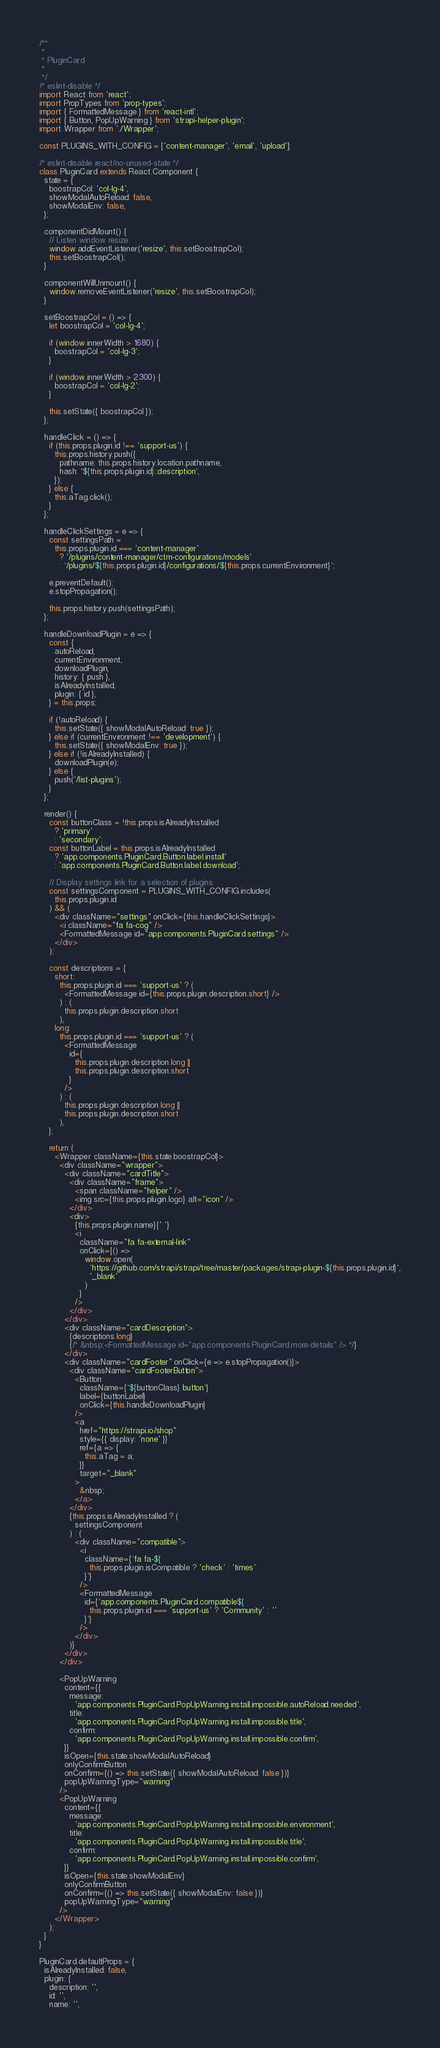<code> <loc_0><loc_0><loc_500><loc_500><_JavaScript_>/**
 *
 * PluginCard
 *
 */
/* eslint-disable */
import React from 'react';
import PropTypes from 'prop-types';
import { FormattedMessage } from 'react-intl';
import { Button, PopUpWarning } from 'strapi-helper-plugin';
import Wrapper from './Wrapper';

const PLUGINS_WITH_CONFIG = ['content-manager', 'email', 'upload'];

/* eslint-disable react/no-unused-state */
class PluginCard extends React.Component {
  state = {
    boostrapCol: 'col-lg-4',
    showModalAutoReload: false,
    showModalEnv: false,
  };

  componentDidMount() {
    // Listen window resize.
    window.addEventListener('resize', this.setBoostrapCol);
    this.setBoostrapCol();
  }

  componentWillUnmount() {
    window.removeEventListener('resize', this.setBoostrapCol);
  }

  setBoostrapCol = () => {
    let boostrapCol = 'col-lg-4';

    if (window.innerWidth > 1680) {
      boostrapCol = 'col-lg-3';
    }

    if (window.innerWidth > 2300) {
      boostrapCol = 'col-lg-2';
    }

    this.setState({ boostrapCol });
  };

  handleClick = () => {
    if (this.props.plugin.id !== 'support-us') {
      this.props.history.push({
        pathname: this.props.history.location.pathname,
        hash: `${this.props.plugin.id}::description`,
      });
    } else {
      this.aTag.click();
    }
  };

  handleClickSettings = e => {
    const settingsPath =
      this.props.plugin.id === 'content-manager'
        ? '/plugins/content-manager/ctm-configurations/models'
        : `/plugins/${this.props.plugin.id}/configurations/${this.props.currentEnvironment}`;

    e.preventDefault();
    e.stopPropagation();

    this.props.history.push(settingsPath);
  };

  handleDownloadPlugin = e => {
    const {
      autoReload,
      currentEnvironment,
      downloadPlugin,
      history: { push },
      isAlreadyInstalled,
      plugin: { id },
    } = this.props;

    if (!autoReload) {
      this.setState({ showModalAutoReload: true });
    } else if (currentEnvironment !== 'development') {
      this.setState({ showModalEnv: true });
    } else if (!isAlreadyInstalled) {
      downloadPlugin(e);
    } else {
      push('/list-plugins');
    }
  };

  render() {
    const buttonClass = !this.props.isAlreadyInstalled
      ? 'primary'
      : 'secondary';
    const buttonLabel = this.props.isAlreadyInstalled
      ? 'app.components.PluginCard.Button.label.install'
      : 'app.components.PluginCard.Button.label.download';

    // Display settings link for a selection of plugins.
    const settingsComponent = PLUGINS_WITH_CONFIG.includes(
      this.props.plugin.id
    ) && (
      <div className="settings" onClick={this.handleClickSettings}>
        <i className="fa fa-cog" />
        <FormattedMessage id="app.components.PluginCard.settings" />
      </div>
    );

    const descriptions = {
      short:
        this.props.plugin.id === 'support-us' ? (
          <FormattedMessage id={this.props.plugin.description.short} />
        ) : (
          this.props.plugin.description.short
        ),
      long:
        this.props.plugin.id === 'support-us' ? (
          <FormattedMessage
            id={
              this.props.plugin.description.long ||
              this.props.plugin.description.short
            }
          />
        ) : (
          this.props.plugin.description.long ||
          this.props.plugin.description.short
        ),
    };

    return (
      <Wrapper className={this.state.boostrapCol}>
        <div className="wrapper">
          <div className="cardTitle">
            <div className="frame">
              <span className="helper" />
              <img src={this.props.plugin.logo} alt="icon" />
            </div>
            <div>
              {this.props.plugin.name}{' '}
              <i
                className="fa fa-external-link"
                onClick={() =>
                  window.open(
                    `https://github.com/strapi/strapi/tree/master/packages/strapi-plugin-${this.props.plugin.id}`,
                    '_blank'
                  )
                }
              />
            </div>
          </div>
          <div className="cardDescription">
            {descriptions.long}
            {/* &nbsp;<FormattedMessage id="app.components.PluginCard.more-details" /> */}
          </div>
          <div className="cardFooter" onClick={e => e.stopPropagation()}>
            <div className="cardFooterButton">
              <Button
                className={`${buttonClass} button`}
                label={buttonLabel}
                onClick={this.handleDownloadPlugin}
              />
              <a
                href="https://strapi.io/shop"
                style={{ display: 'none' }}
                ref={a => {
                  this.aTag = a;
                }}
                target="_blank"
              >
                &nbsp;
              </a>
            </div>
            {this.props.isAlreadyInstalled ? (
              settingsComponent
            ) : (
              <div className="compatible">
                <i
                  className={`fa fa-${
                    this.props.plugin.isCompatible ? 'check' : 'times'
                  }`}
                />
                <FormattedMessage
                  id={`app.components.PluginCard.compatible${
                    this.props.plugin.id === 'support-us' ? 'Community' : ''
                  }`}
                />
              </div>
            )}
          </div>
        </div>

        <PopUpWarning
          content={{
            message:
              'app.components.PluginCard.PopUpWarning.install.impossible.autoReload.needed',
            title:
              'app.components.PluginCard.PopUpWarning.install.impossible.title',
            confirm:
              'app.components.PluginCard.PopUpWarning.install.impossible.confirm',
          }}
          isOpen={this.state.showModalAutoReload}
          onlyConfirmButton
          onConfirm={() => this.setState({ showModalAutoReload: false })}
          popUpWarningType="warning"
        />
        <PopUpWarning
          content={{
            message:
              'app.components.PluginCard.PopUpWarning.install.impossible.environment',
            title:
              'app.components.PluginCard.PopUpWarning.install.impossible.title',
            confirm:
              'app.components.PluginCard.PopUpWarning.install.impossible.confirm',
          }}
          isOpen={this.state.showModalEnv}
          onlyConfirmButton
          onConfirm={() => this.setState({ showModalEnv: false })}
          popUpWarningType="warning"
        />
      </Wrapper>
    );
  }
}

PluginCard.defaultProps = {
  isAlreadyInstalled: false,
  plugin: {
    description: '',
    id: '',
    name: '',</code> 